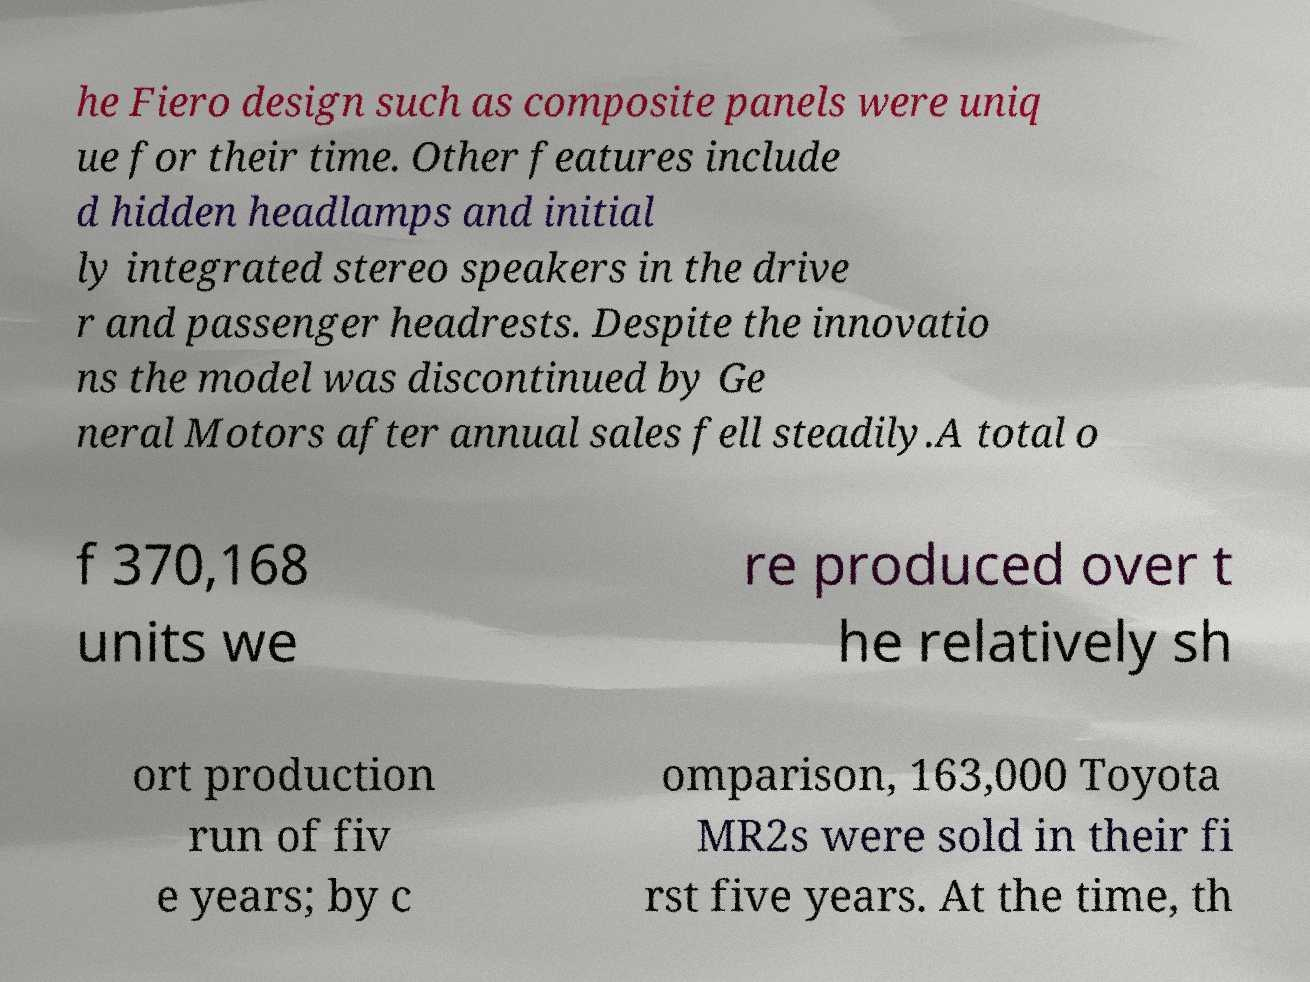Could you assist in decoding the text presented in this image and type it out clearly? he Fiero design such as composite panels were uniq ue for their time. Other features include d hidden headlamps and initial ly integrated stereo speakers in the drive r and passenger headrests. Despite the innovatio ns the model was discontinued by Ge neral Motors after annual sales fell steadily.A total o f 370,168 units we re produced over t he relatively sh ort production run of fiv e years; by c omparison, 163,000 Toyota MR2s were sold in their fi rst five years. At the time, th 